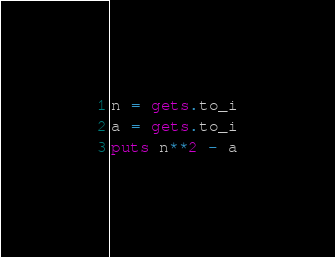Convert code to text. <code><loc_0><loc_0><loc_500><loc_500><_Ruby_>n = gets.to_i
a = gets.to_i
puts n**2 - a</code> 